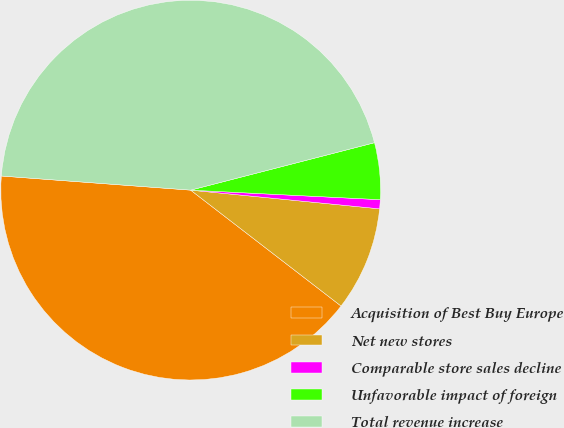Convert chart to OTSL. <chart><loc_0><loc_0><loc_500><loc_500><pie_chart><fcel>Acquisition of Best Buy Europe<fcel>Net new stores<fcel>Comparable store sales decline<fcel>Unfavorable impact of foreign<fcel>Total revenue increase<nl><fcel>40.74%<fcel>8.88%<fcel>0.77%<fcel>4.82%<fcel>44.8%<nl></chart> 